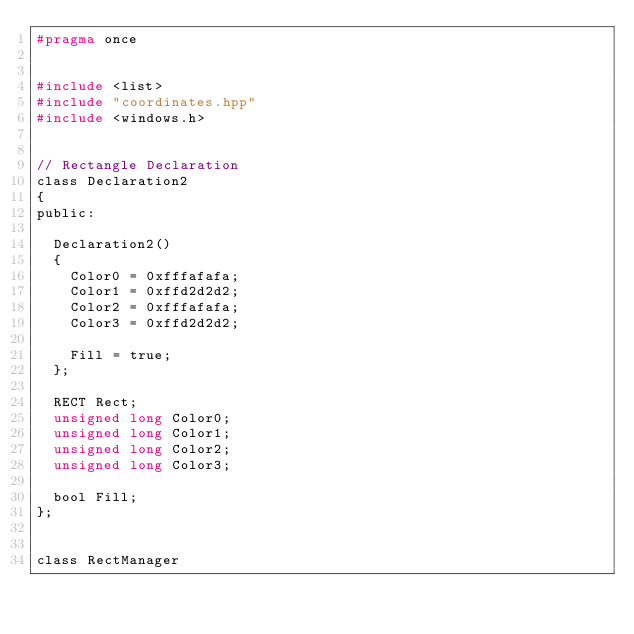<code> <loc_0><loc_0><loc_500><loc_500><_C_>#pragma once


#include <list>
#include "coordinates.hpp"
#include <windows.h>


// Rectangle Declaration
class Declaration2
{
public:

	Declaration2()
	{
		Color0 = 0xfffafafa;
		Color1 = 0xffd2d2d2;
		Color2 = 0xfffafafa;
		Color3 = 0xffd2d2d2;

		Fill = true;
	};

	RECT Rect;
	unsigned long Color0;
	unsigned long Color1;
	unsigned long Color2;
	unsigned long Color3;

	bool Fill;
};


class RectManager</code> 